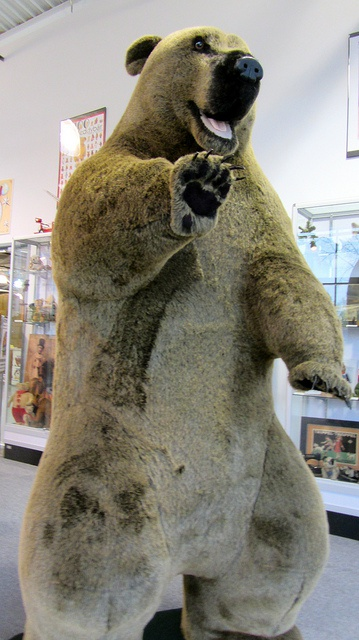Describe the objects in this image and their specific colors. I can see a bear in darkgray, gray, black, and darkgreen tones in this image. 